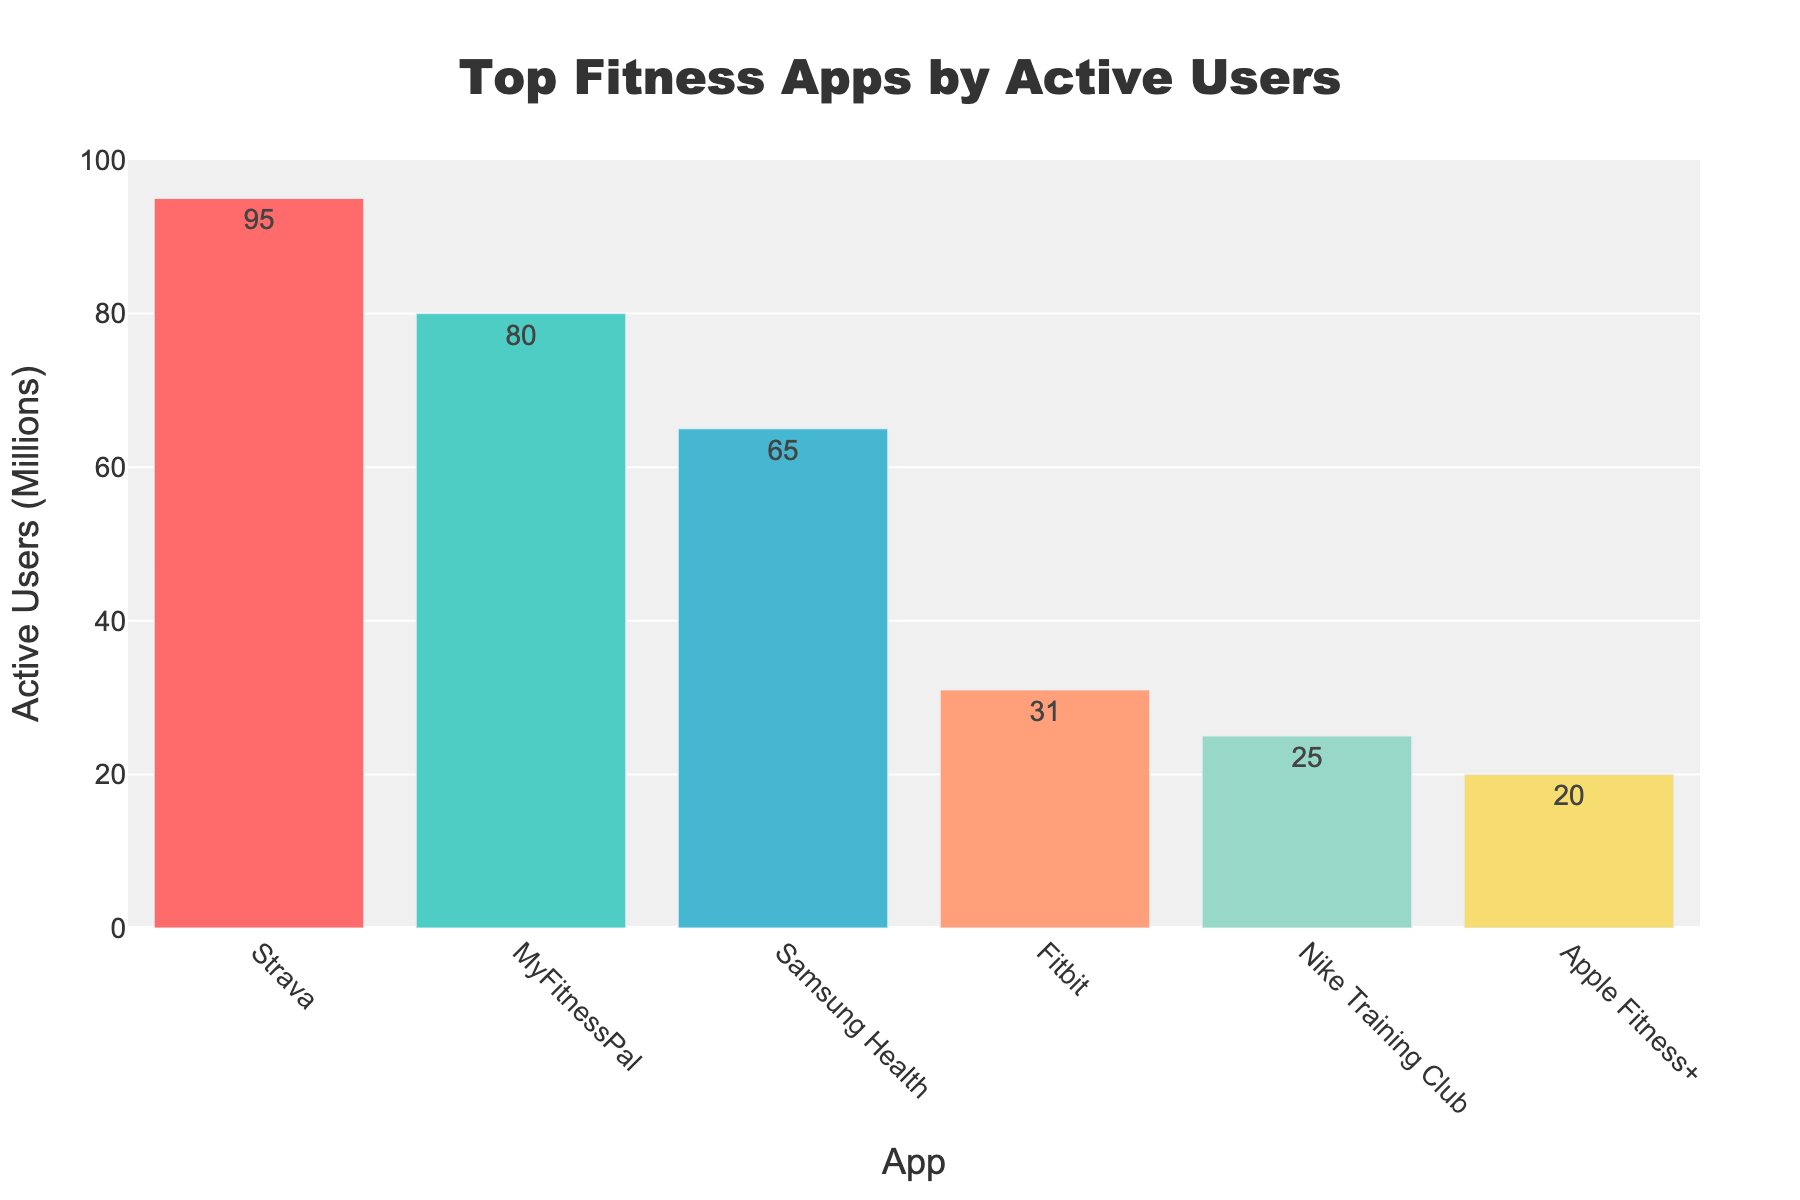How many active users do the top three apps have in total? The top three apps are Strava, MyFitnessPal, and Samsung Health with active users of 95 million, 80 million, and 65 million respectively. Summing these gives 95 + 80 + 65 = 240 million.
Answer: 240 million Which app has the most active users and what is its primary feature? The app with the most active users is Strava with 95 million active users. Its primary features include GPS tracking, social networking, and performance analysis.
Answer: Strava What is the difference in the number of active users between MyFitnessPal and Fitbit? MyFitnessPal has 80 million active users while Fitbit has 31 million active users. The difference is 80 - 31 = 49 million.
Answer: 49 million Which app has the least active users and what are its primary features? Apple Fitness+ has the least active users with 20 million. Its primary features include guided workouts, integration with Apple Watch, and personalized recommendations.
Answer: Apple Fitness+ Between Nike Training Club and Samsung Health, which app has more active users and by how much? Samsung Health has 65 million active users while Nike Training Club has 25 million active users. Samsung Health has 65 - 25 = 40 million more active users.
Answer: 40 million What are the combined active users of the apps with red and blue bars? The apps with red and blue bars are MyFitnessPal (80 million) and Strava (95 million) respectively. Their combined active users are 80 + 95 = 175 million.
Answer: 175 million Visually, which three apps have bars that are significantly higher than the others? Visually, Strava, MyFitnessPal, and Samsung Health have bars that are significantly higher than the others. These heights represent their higher number of active users.
Answer: Strava, MyFitnessPal, Samsung Health What is the average number of active users across all apps? The total number of active users across all apps is 95 + 80 + 65 + 31 + 25 + 20 = 316 million. There are six apps, so the average is 316 million / 6 ≈ 52.67 million.
Answer: 52.67 million How does the number of active users of Fitbit compare to Nike Training Club, and what are their primary features? Fitbit has 31 million active users while Nike Training Club has 25 million. Fitbit has more active users by 31 - 25 = 6 million. Fitbit’s primary features are step tracking, sleep analysis, and heart rate monitoring. Nike Training Club's primary features are workout videos, personalized training plans, and progress tracking.
Answer: Fitbit has 6 million more active users; step tracking, sleep analysis, heart rate monitoring; workout videos, personalized training plans, progress tracking 